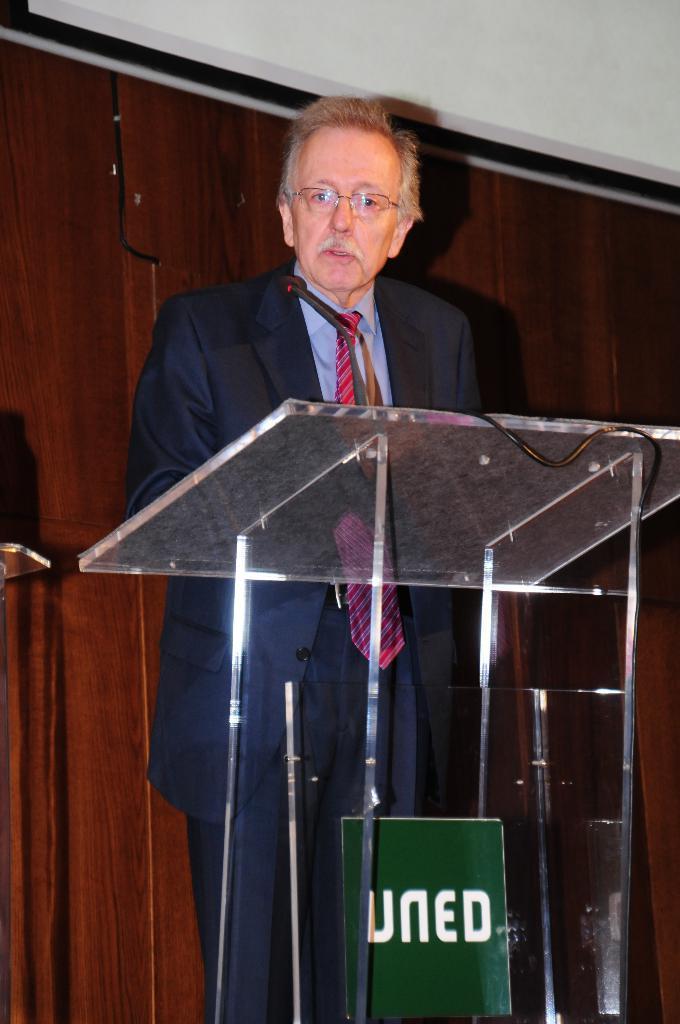Please provide a concise description of this image. As we can see in the image there are cupboards and a man wearing blue color suit. 